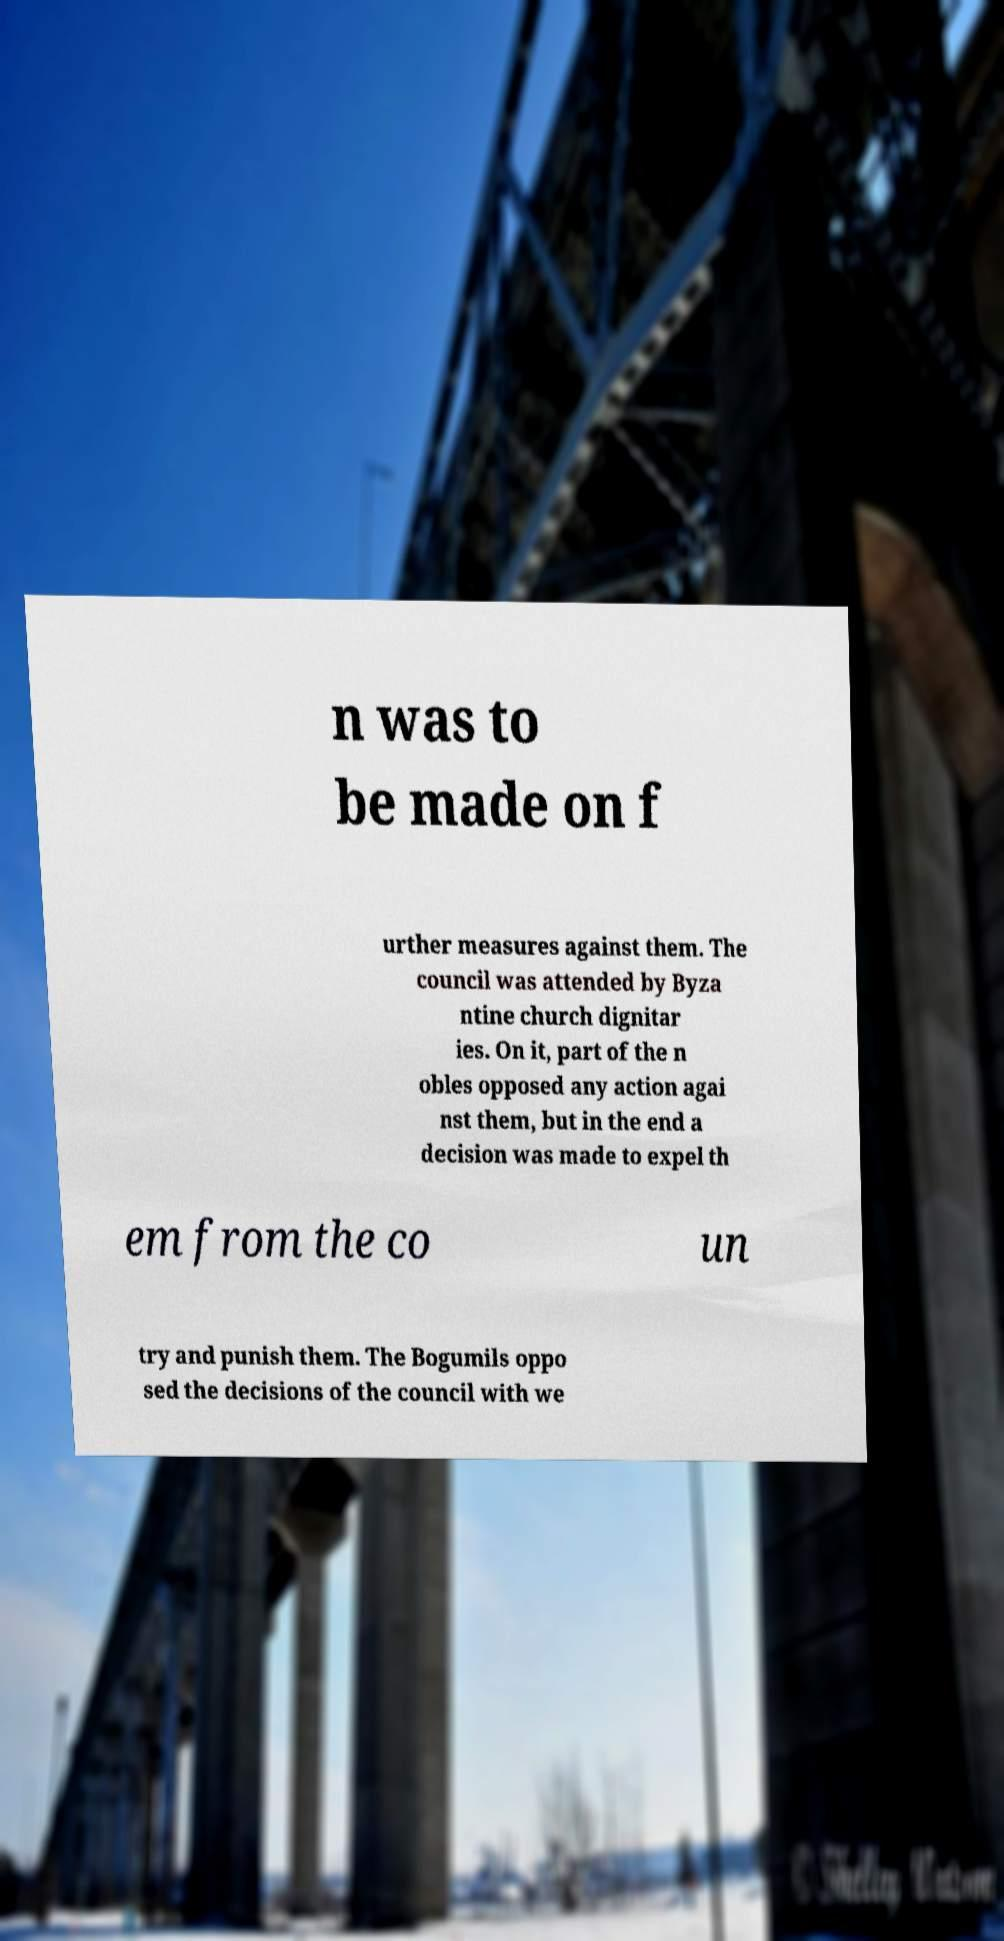For documentation purposes, I need the text within this image transcribed. Could you provide that? n was to be made on f urther measures against them. The council was attended by Byza ntine church dignitar ies. On it, part of the n obles opposed any action agai nst them, but in the end a decision was made to expel th em from the co un try and punish them. The Bogumils oppo sed the decisions of the council with we 